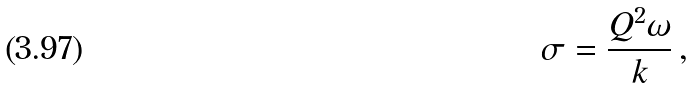Convert formula to latex. <formula><loc_0><loc_0><loc_500><loc_500>\sigma = \frac { Q ^ { 2 } \omega } { k } \, ,</formula> 